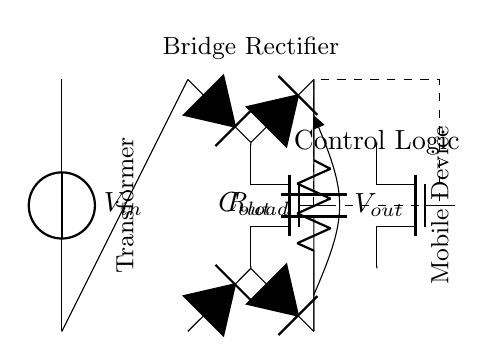What is the input voltage of this circuit? The input voltage is labeled as V_in, which indicates the voltage supplied to the circuit from the power source.
Answer: V_in What are the main components in this rectifier circuit? The circuit includes a voltage source, a transformer, a bridge rectifier, two MOSFETs, control logic, an output capacitor, and a load resistor.
Answer: Voltage source, transformer, bridge rectifier, MOSFETs, control logic, output capacitor, load resistor What is the purpose of the control logic in this circuit? The control logic manages the operation of the synchronous rectifier MOSFETs to improve efficiency by minimizing conduction losses when converting AC to DC.
Answer: Efficiency improvement How many MOSFETs are used in the synchronous rectifier? There are two MOSFETs (M1 and M2) utilized in the synchronous rectifier to control the current flow efficiently.
Answer: Two What is the role of the output capacitor in this circuit? The output capacitor (C_out) smooths the output voltage by reducing ripple and providing stable voltage to the load.
Answer: Smoothing output voltage What type of rectification does this circuit perform? This circuit performs synchronous rectification, which uses active devices (MOSFETs) for more efficient rectification compared to traditional diode-based rectification.
Answer: Synchronous rectification What is the load connected to this circuit referred to as? The load is referred to as R_load, which represents the device being charged (e.g., a mobile device).
Answer: Mobile device 